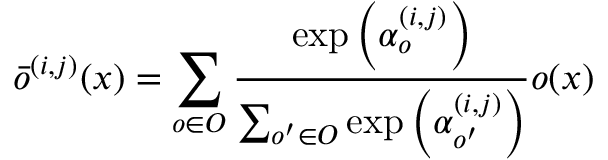Convert formula to latex. <formula><loc_0><loc_0><loc_500><loc_500>{ \bar { o } ^ { ( i , j ) } } ( x ) = \sum _ { o \in O } { \frac { { \exp \left ( { \alpha _ { o } ^ { ( i , j ) } } \right ) } } { { \sum _ { o ^ { \prime } \in O } { \exp \left ( { \alpha _ { o ^ { \prime } } ^ { ( i , j ) } } \right ) } } } o ( x ) }</formula> 